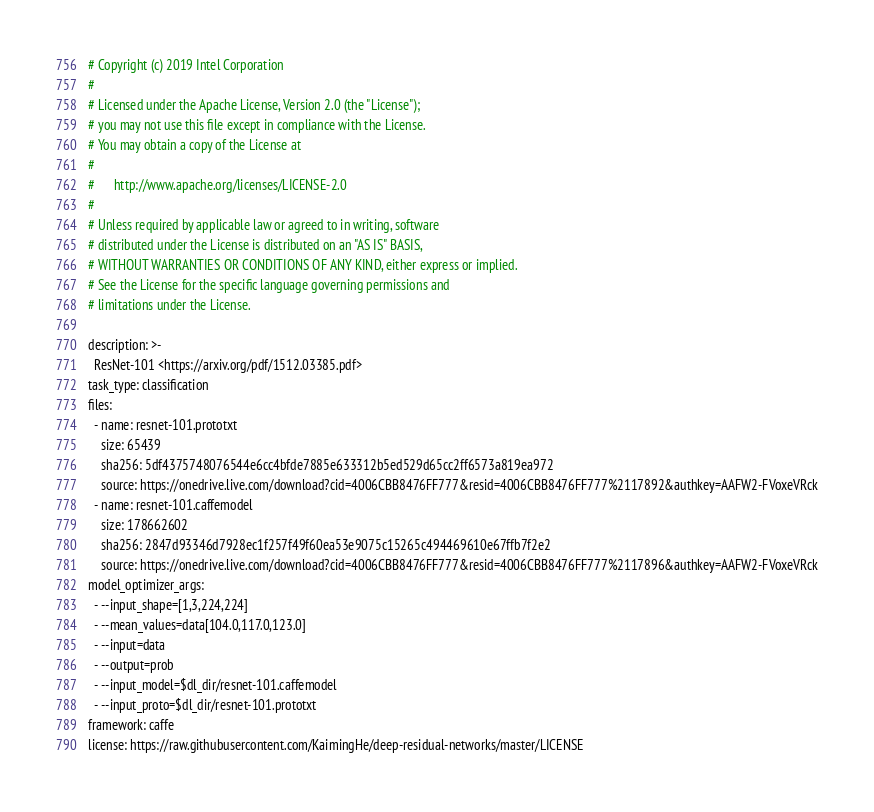Convert code to text. <code><loc_0><loc_0><loc_500><loc_500><_YAML_># Copyright (c) 2019 Intel Corporation
#
# Licensed under the Apache License, Version 2.0 (the "License");
# you may not use this file except in compliance with the License.
# You may obtain a copy of the License at
#
#      http://www.apache.org/licenses/LICENSE-2.0
#
# Unless required by applicable law or agreed to in writing, software
# distributed under the License is distributed on an "AS IS" BASIS,
# WITHOUT WARRANTIES OR CONDITIONS OF ANY KIND, either express or implied.
# See the License for the specific language governing permissions and
# limitations under the License.

description: >-
  ResNet-101 <https://arxiv.org/pdf/1512.03385.pdf>
task_type: classification
files:
  - name: resnet-101.prototxt
    size: 65439
    sha256: 5df4375748076544e6cc4bfde7885e633312b5ed529d65cc2ff6573a819ea972
    source: https://onedrive.live.com/download?cid=4006CBB8476FF777&resid=4006CBB8476FF777%2117892&authkey=AAFW2-FVoxeVRck
  - name: resnet-101.caffemodel
    size: 178662602
    sha256: 2847d93346d7928ec1f257f49f60ea53e9075c15265c494469610e67ffb7f2e2
    source: https://onedrive.live.com/download?cid=4006CBB8476FF777&resid=4006CBB8476FF777%2117896&authkey=AAFW2-FVoxeVRck
model_optimizer_args:
  - --input_shape=[1,3,224,224]
  - --mean_values=data[104.0,117.0,123.0]
  - --input=data
  - --output=prob
  - --input_model=$dl_dir/resnet-101.caffemodel
  - --input_proto=$dl_dir/resnet-101.prototxt
framework: caffe
license: https://raw.githubusercontent.com/KaimingHe/deep-residual-networks/master/LICENSE
</code> 